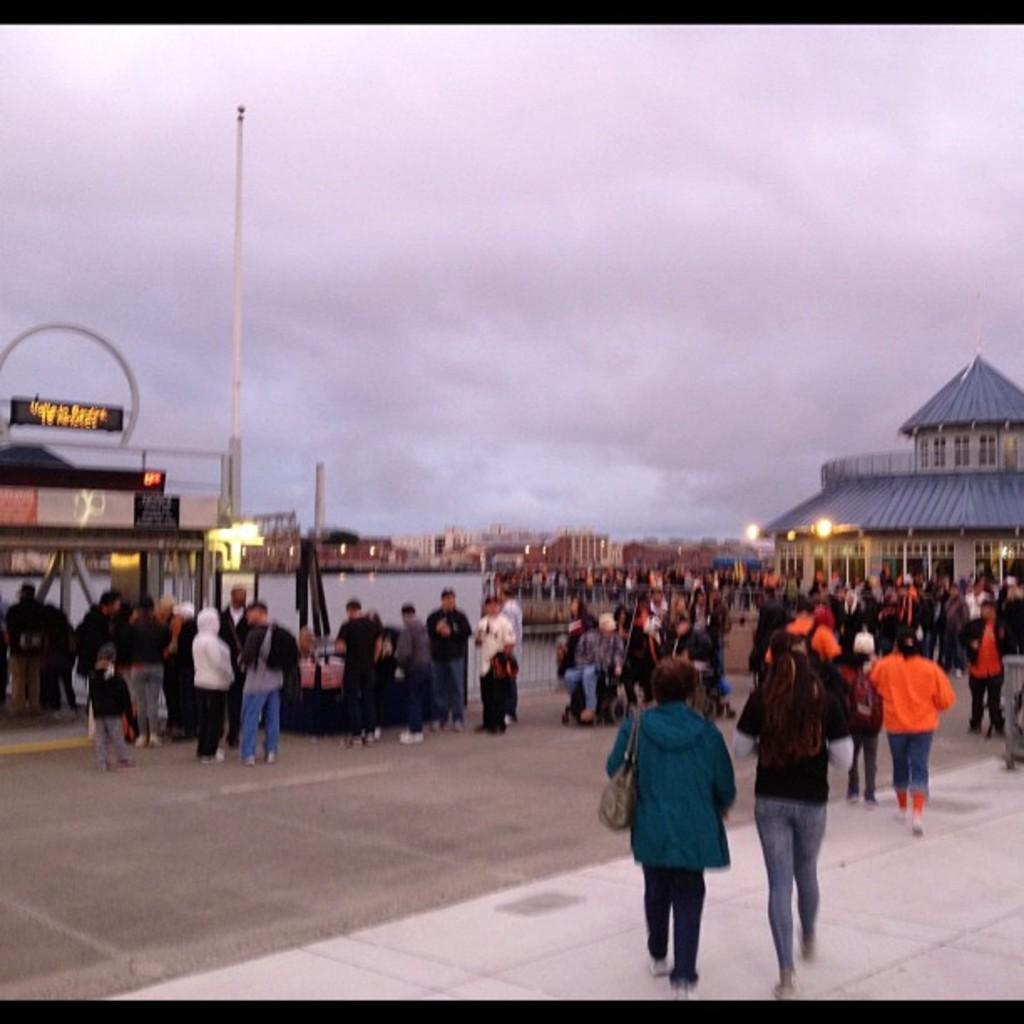Describe this image in one or two sentences. In the foreground of this image, there are people standing and walking on the ground. We can also see buildings, poles, lights and the sky. 